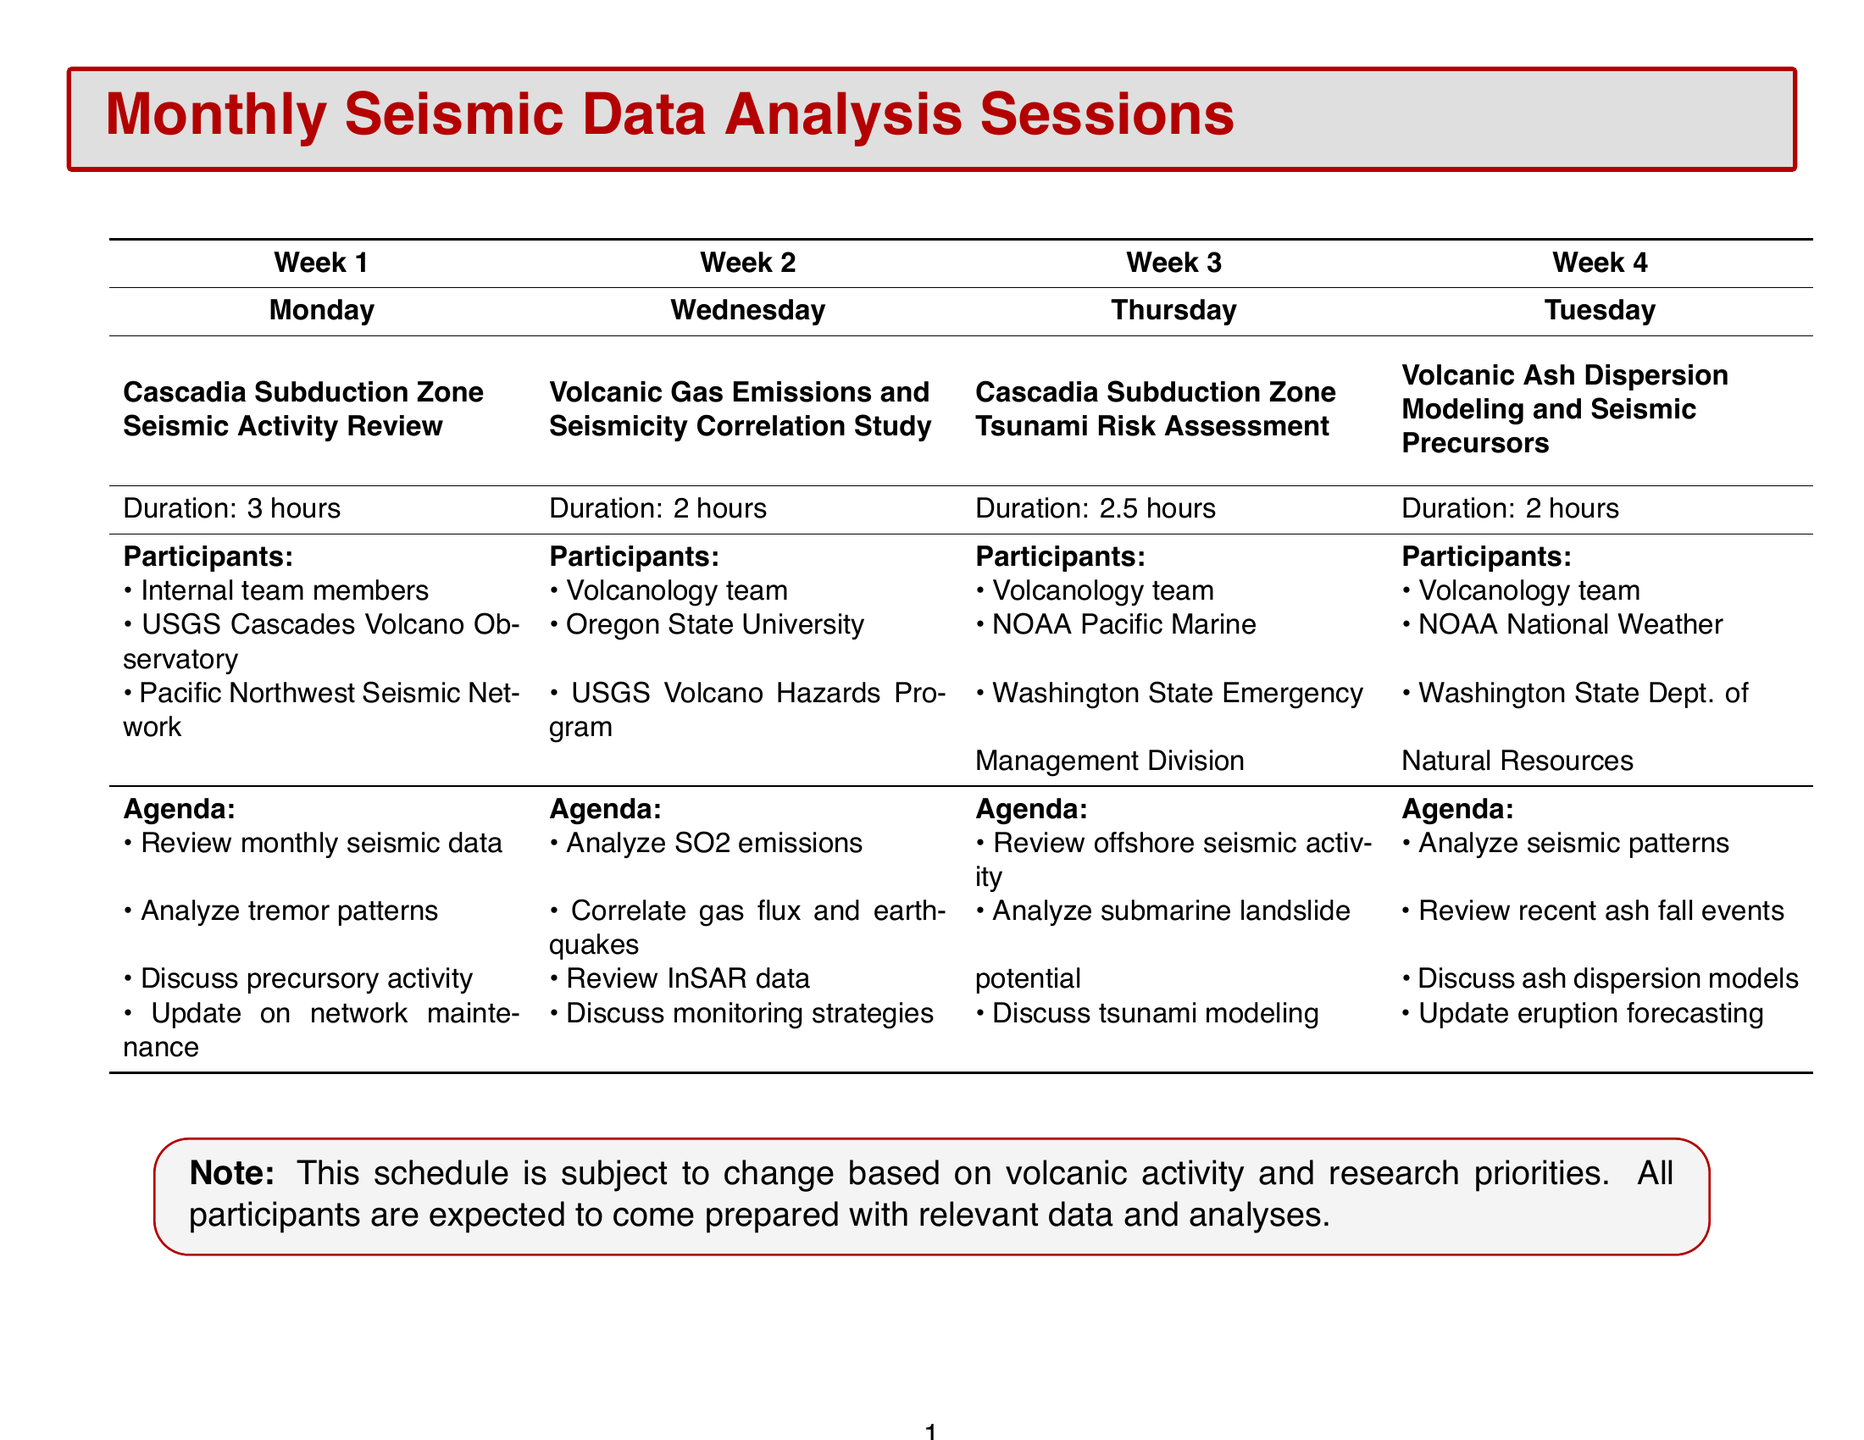What is the frequency of the "Cascadia Subduction Zone Seismic Activity Review"? The frequency can be found in the session details, specifically indicating the first Monday of every month.
Answer: First Monday of every month How long does the "Volcanic Gas Emissions and Seismicity Correlation Study" session last? The duration is explicitly stated in the schedule for this session.
Answer: 2 hours Who are the participants in the "Cascadia Subduction Zone Tsunami Risk Assessment"? This information lists all the individuals or organizations involved in this session.
Answer: Volcanology team, NOAA Pacific Marine Environmental Laboratory scientists, Washington State Emergency Management Division representatives What is one agenda item for the "Volcanic Ash Dispersion Modeling and Seismic Precursors"? Agenda items detail the topics discussed in this session, and one of them is being requested.
Answer: Analysis of seismic patterns preceding historical ash emissions Which week does the "Volcanic Gas Emissions and Seismicity Correlation Study" occur? The schedule allocates specific weeks for each session, where the second Wednesday indicates the week number.
Answer: Week 2 What topic is discussed regarding Mount Rainier? This session's agenda outlines specific subjects, including one focused on Mount Rainier.
Answer: Review of monthly seismic data from Mount Rainier What is the total duration of all monthly seismic data analysis sessions when combined? Each session has a defined duration, which can be added together for the total across the month.
Answer: 9.5 hours What is the primary focus of the "Cascadia Subduction Zone Seismic Activity Review"? The main theme of this session can be inferred from its title and agenda items.
Answer: Seismic activity review How often are the analysis sessions scheduled? The document provides specific frequencies for each session to determine how regularly they occur.
Answer: Monthly 